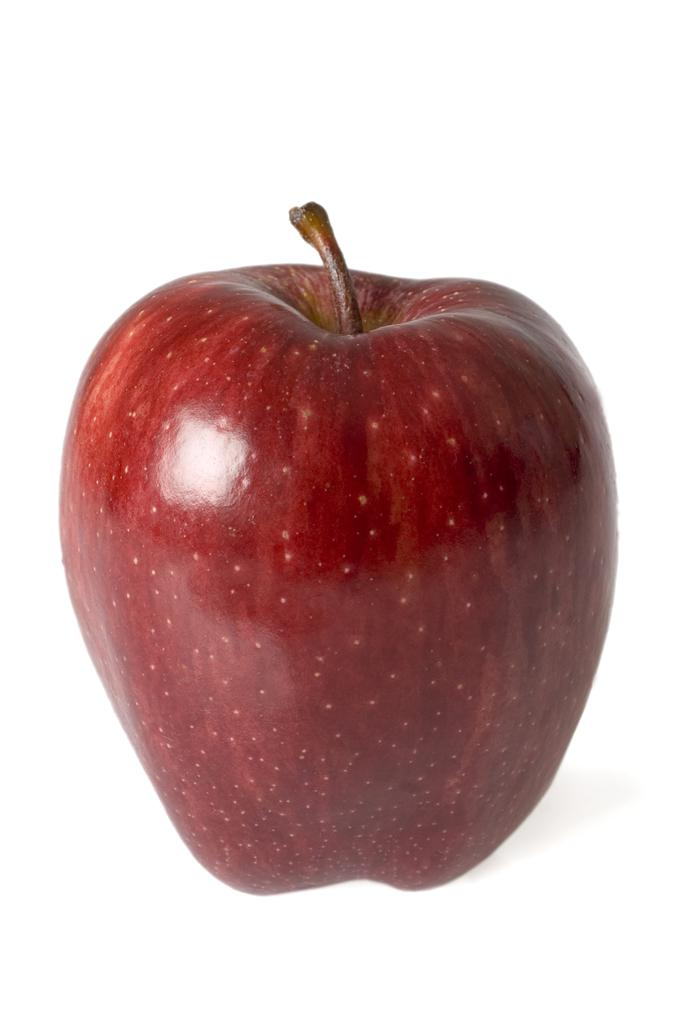What is the main subject of the image? There is an apple in the image. What can be seen in the background of the image? The background of the image is white. How many socks can be seen on the apple in the image? There are no socks present in the image, as it features an apple with a white background. Is there a beggar visible in the image? There is no beggar present in the image, as it features an apple with a white background. 